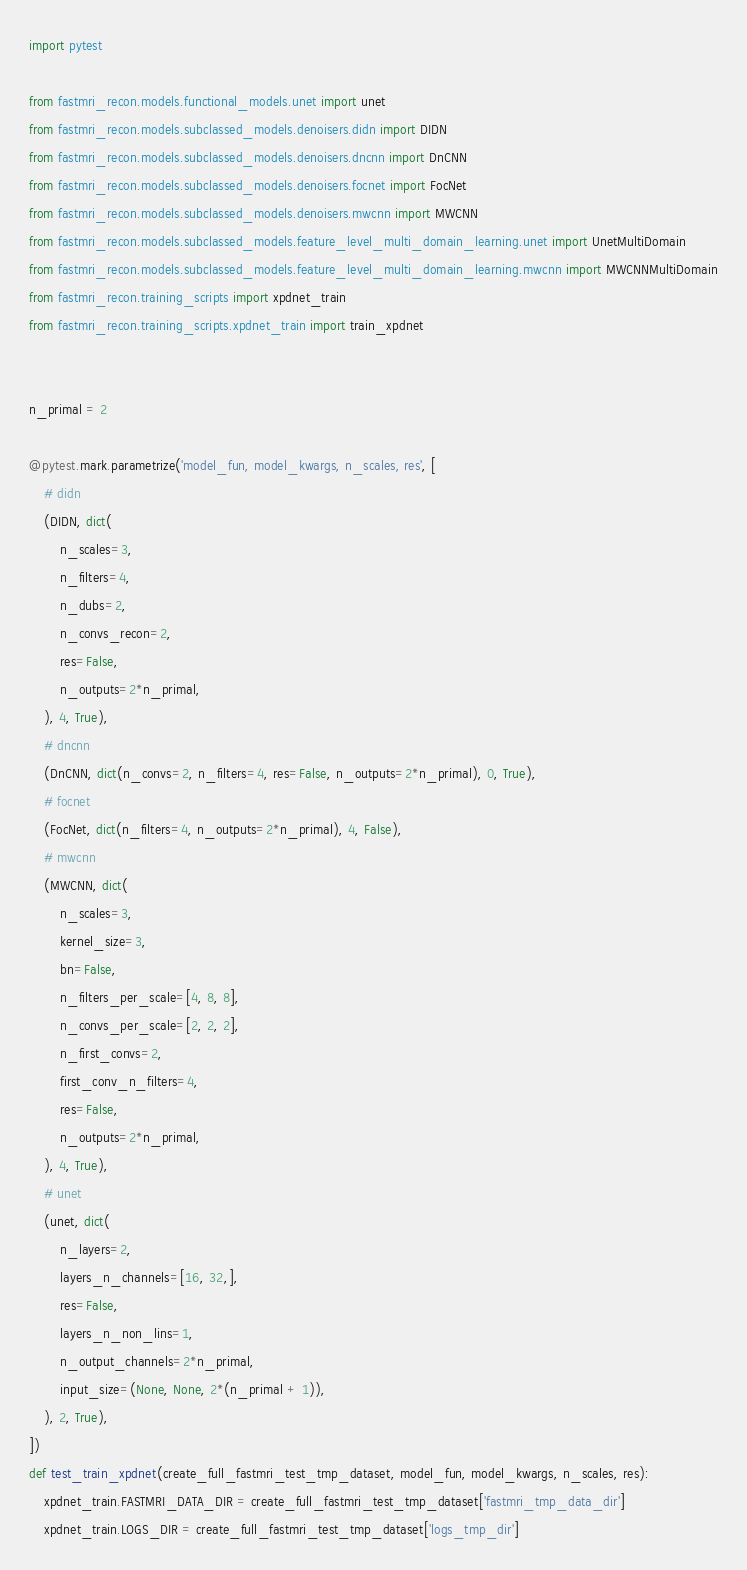<code> <loc_0><loc_0><loc_500><loc_500><_Python_>import pytest

from fastmri_recon.models.functional_models.unet import unet
from fastmri_recon.models.subclassed_models.denoisers.didn import DIDN
from fastmri_recon.models.subclassed_models.denoisers.dncnn import DnCNN
from fastmri_recon.models.subclassed_models.denoisers.focnet import FocNet
from fastmri_recon.models.subclassed_models.denoisers.mwcnn import MWCNN
from fastmri_recon.models.subclassed_models.feature_level_multi_domain_learning.unet import UnetMultiDomain
from fastmri_recon.models.subclassed_models.feature_level_multi_domain_learning.mwcnn import MWCNNMultiDomain
from fastmri_recon.training_scripts import xpdnet_train
from fastmri_recon.training_scripts.xpdnet_train import train_xpdnet


n_primal = 2

@pytest.mark.parametrize('model_fun, model_kwargs, n_scales, res', [
    # didn
    (DIDN, dict(
        n_scales=3,
        n_filters=4,
        n_dubs=2,
        n_convs_recon=2,
        res=False,
        n_outputs=2*n_primal,
    ), 4, True),
    # dncnn
    (DnCNN, dict(n_convs=2, n_filters=4, res=False, n_outputs=2*n_primal), 0, True),
    # focnet
    (FocNet, dict(n_filters=4, n_outputs=2*n_primal), 4, False),
    # mwcnn
    (MWCNN, dict(
        n_scales=3,
        kernel_size=3,
        bn=False,
        n_filters_per_scale=[4, 8, 8],
        n_convs_per_scale=[2, 2, 2],
        n_first_convs=2,
        first_conv_n_filters=4,
        res=False,
        n_outputs=2*n_primal,
    ), 4, True),
    # unet
    (unet, dict(
        n_layers=2,
        layers_n_channels=[16, 32,],
        res=False,
        layers_n_non_lins=1,
        n_output_channels=2*n_primal,
        input_size=(None, None, 2*(n_primal + 1)),
    ), 2, True),
])
def test_train_xpdnet(create_full_fastmri_test_tmp_dataset, model_fun, model_kwargs, n_scales, res):
    xpdnet_train.FASTMRI_DATA_DIR = create_full_fastmri_test_tmp_dataset['fastmri_tmp_data_dir']
    xpdnet_train.LOGS_DIR = create_full_fastmri_test_tmp_dataset['logs_tmp_dir']</code> 